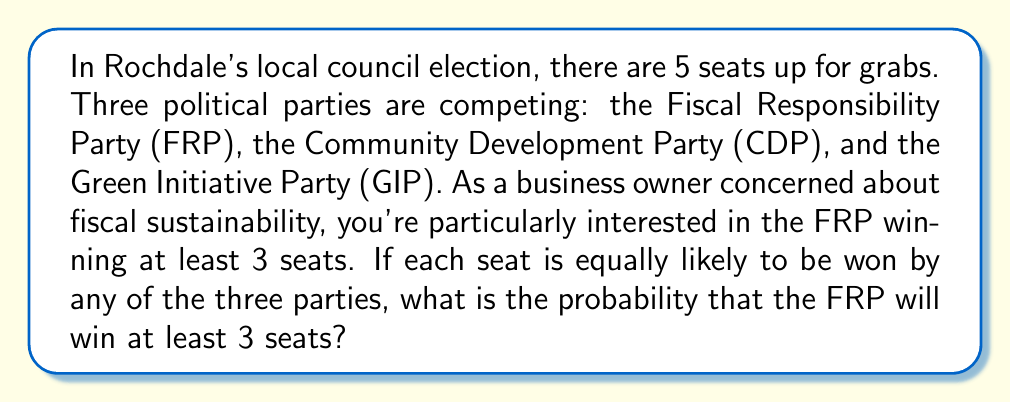Give your solution to this math problem. Let's approach this step-by-step:

1) First, we need to calculate the total number of possible outcomes. With 3 parties competing for 5 seats, we have 3 choices for each seat. This gives us:

   $$ \text{Total outcomes} = 3^5 = 243 $$

2) Now, we need to calculate the number of favorable outcomes (FRP winning at least 3 seats). We can break this down into three scenarios:
   
   a) FRP wins 3 seats: $\binom{5}{3} \cdot 2^2 = 10 \cdot 4 = 40$ ways
   b) FRP wins 4 seats: $\binom{5}{4} \cdot 2^1 = 5 \cdot 2 = 10$ ways
   c) FRP wins 5 seats: $\binom{5}{5} = 1$ way

3) The total number of favorable outcomes is the sum of these:

   $$ \text{Favorable outcomes} = 40 + 10 + 1 = 51 $$

4) The probability is then the number of favorable outcomes divided by the total number of outcomes:

   $$ P(\text{FRP wins at least 3 seats}) = \frac{51}{243} = \frac{17}{81} \approx 0.2099 $$
Answer: $\frac{17}{81}$ 